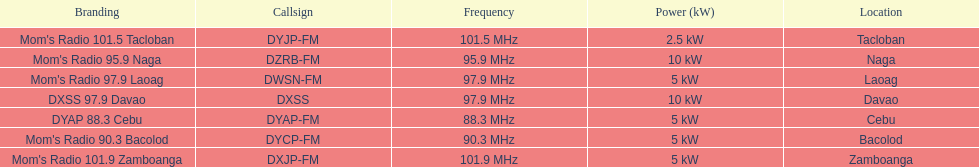What is the radio with the most mhz? Mom's Radio 101.9 Zamboanga. 